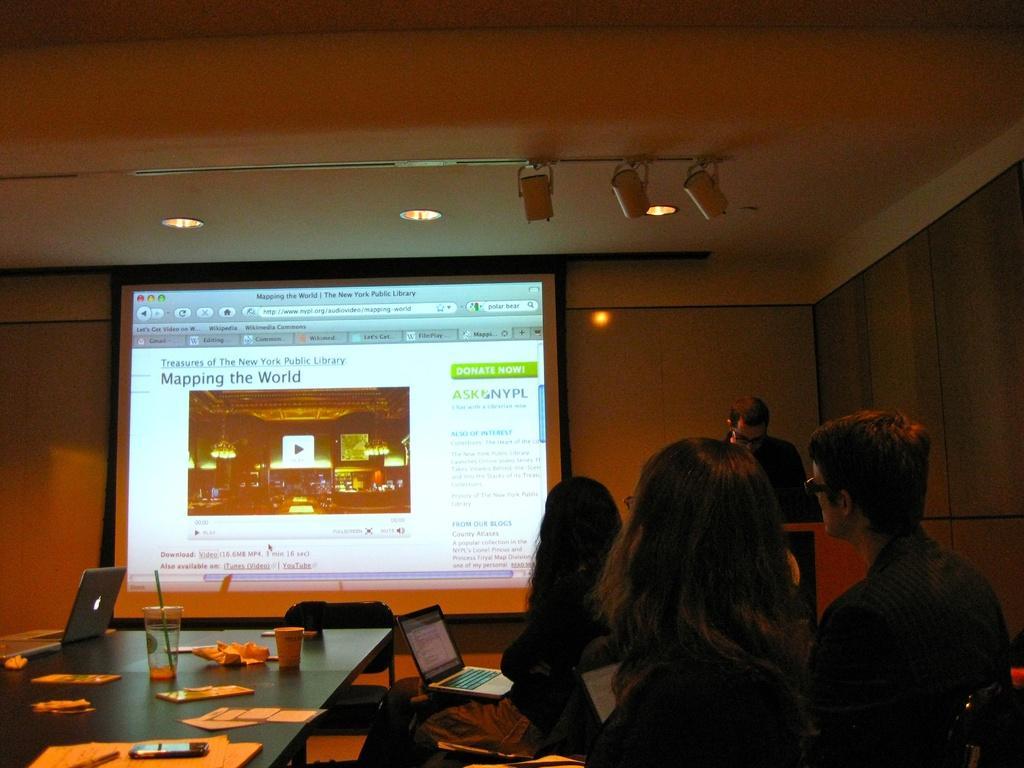Could you give a brief overview of what you see in this image? In the front of the image we can see people are sitting on chairs. Above the table there is a laptop, papers, mobile, cup, glass and things. Near that woman there is a laptop. In the background there is a wall, screen, ceiling lights, focusing lights, person and podium. We can see an image and something is written on the screen.   